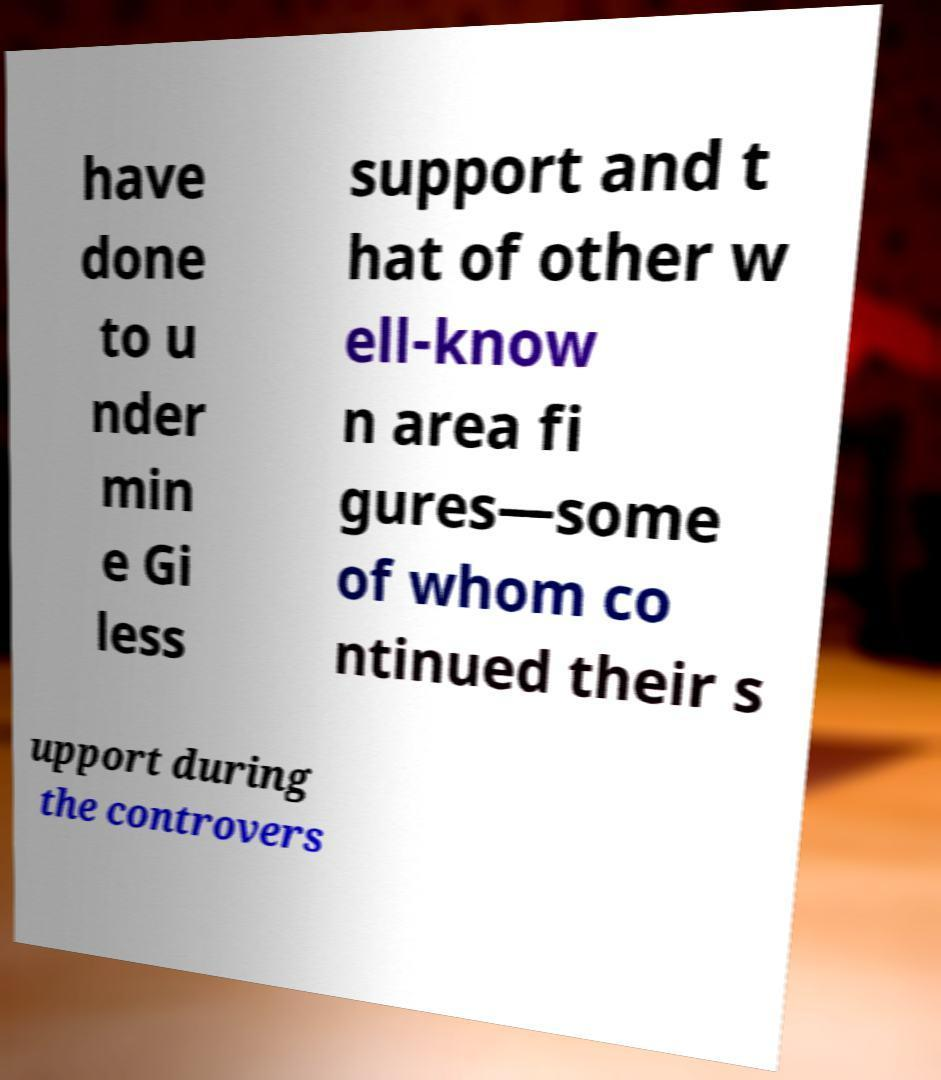For documentation purposes, I need the text within this image transcribed. Could you provide that? have done to u nder min e Gi less support and t hat of other w ell-know n area fi gures—some of whom co ntinued their s upport during the controvers 